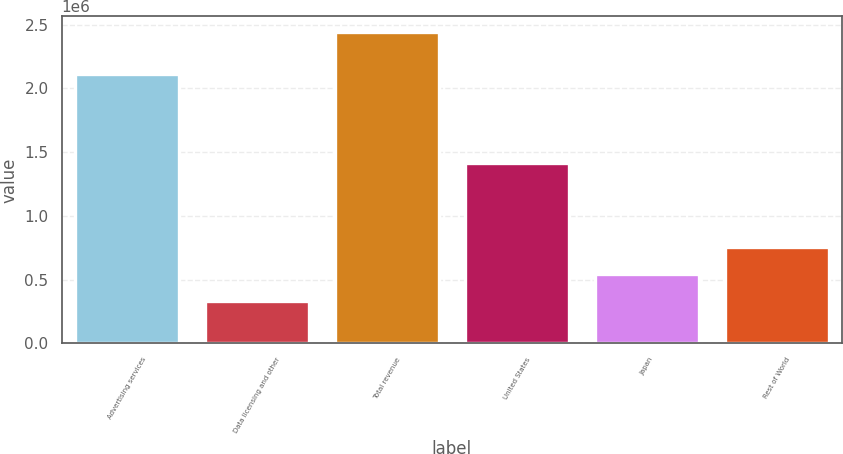<chart> <loc_0><loc_0><loc_500><loc_500><bar_chart><fcel>Advertising services<fcel>Data licensing and other<fcel>Total revenue<fcel>United States<fcel>Japan<fcel>Rest of World<nl><fcel>2.10999e+06<fcel>333312<fcel>2.4433e+06<fcel>1.41361e+06<fcel>544311<fcel>755309<nl></chart> 